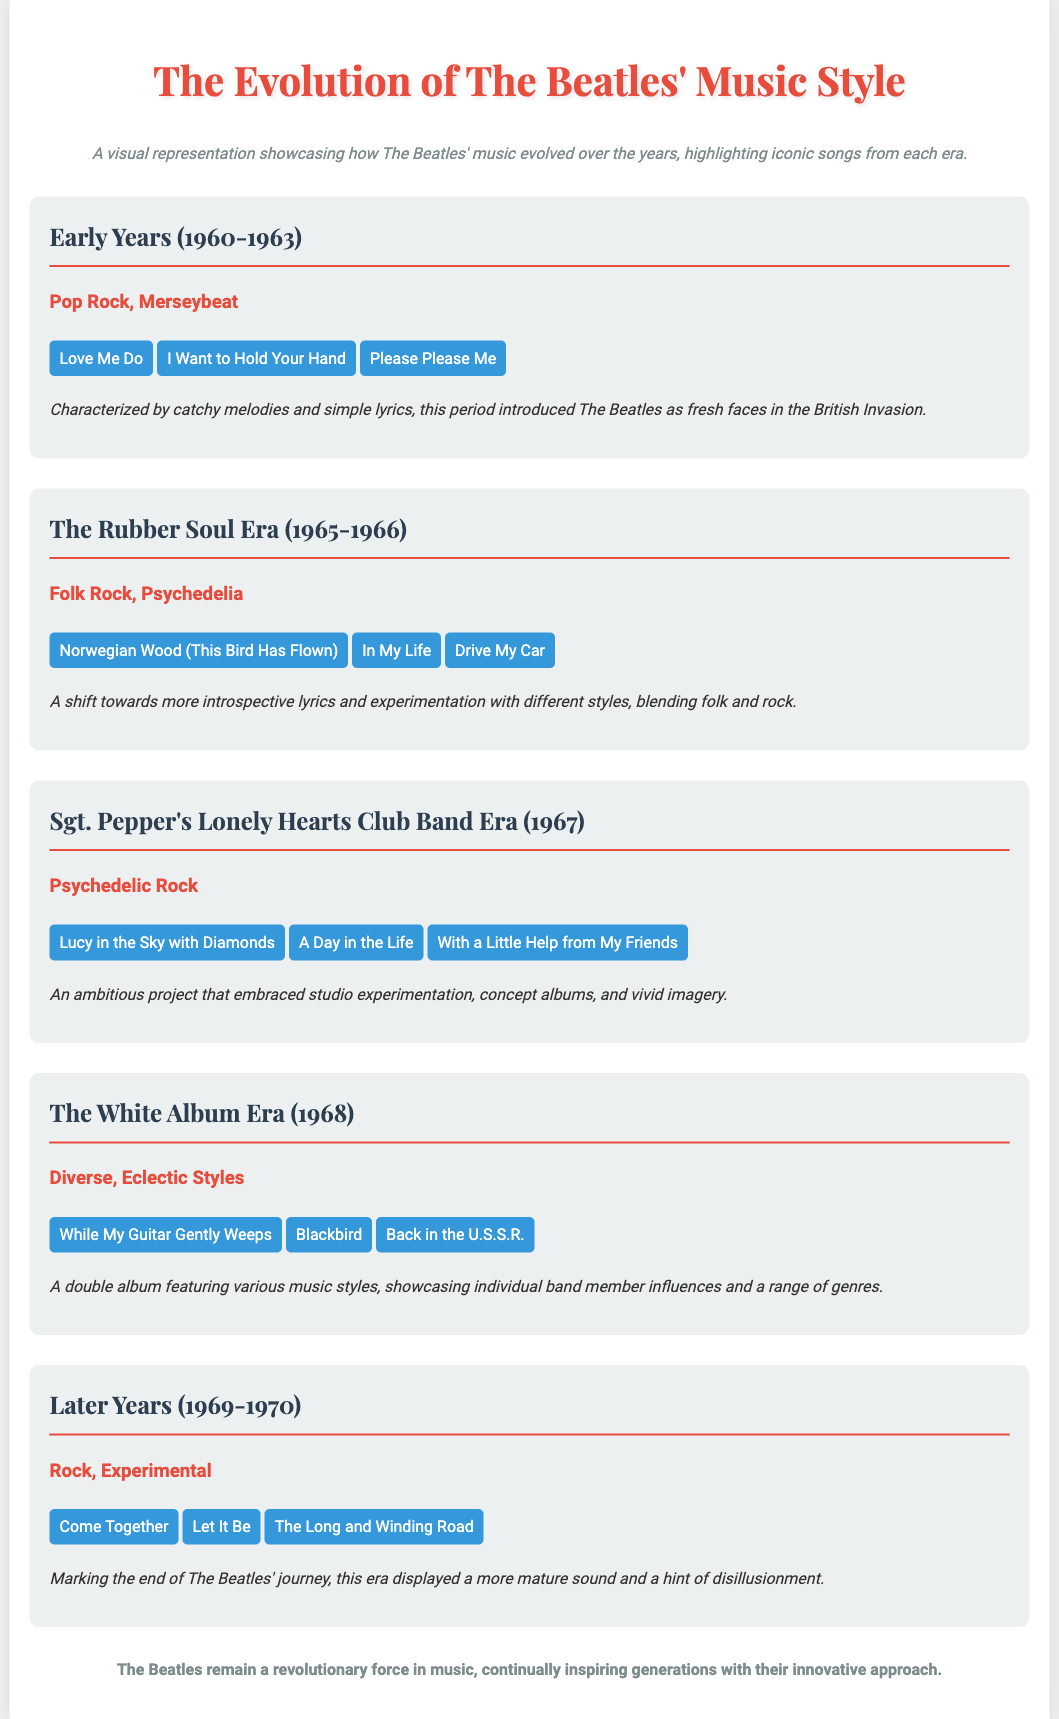What are some of The Beatles' best songs from the Early Years? The section lists three iconic songs from the Early Years era (1960-1963): "Love Me Do," "I Want to Hold Your Hand," and "Please Please Me."
Answer: Love Me Do, I Want to Hold Your Hand, Please Please Me What music style is associated with the Sgt. Pepper's Lonely Hearts Club Band Era? The document specifies that the music style during this era (1967) is "Psychedelic Rock."
Answer: Psychedelic Rock How many eras are showcased in the document? The document lists five distinct eras showcasing The Beatles' evolution in music.
Answer: 5 What song from The White Album Era features individual band member influences? The White Album Era includes a double album featuring various music styles, one of which is "While My Guitar Gently Weeps."
Answer: While My Guitar Gently Weeps What describes the lyrical content of The Rubber Soul Era? The document notes that this period (1965-1966) is characterized by more introspective lyrics and experimentation with different styles.
Answer: More introspective lyrics and experimentation What year marks the end of The Beatles' journey? According to the document, the Later Years span from 1969 to 1970, marking the end of The Beatles' journey.
Answer: 1970 Which song is mentioned as representative of the Later Years? The Later Years section includes "Come Together" as one of the representative songs from that period.
Answer: Come Together What is the main characteristic of the music in the Early Years? The document mentions that catchy melodies and simple lyrics characterized the music style during the Early Years.
Answer: Catchy melodies and simple lyrics 